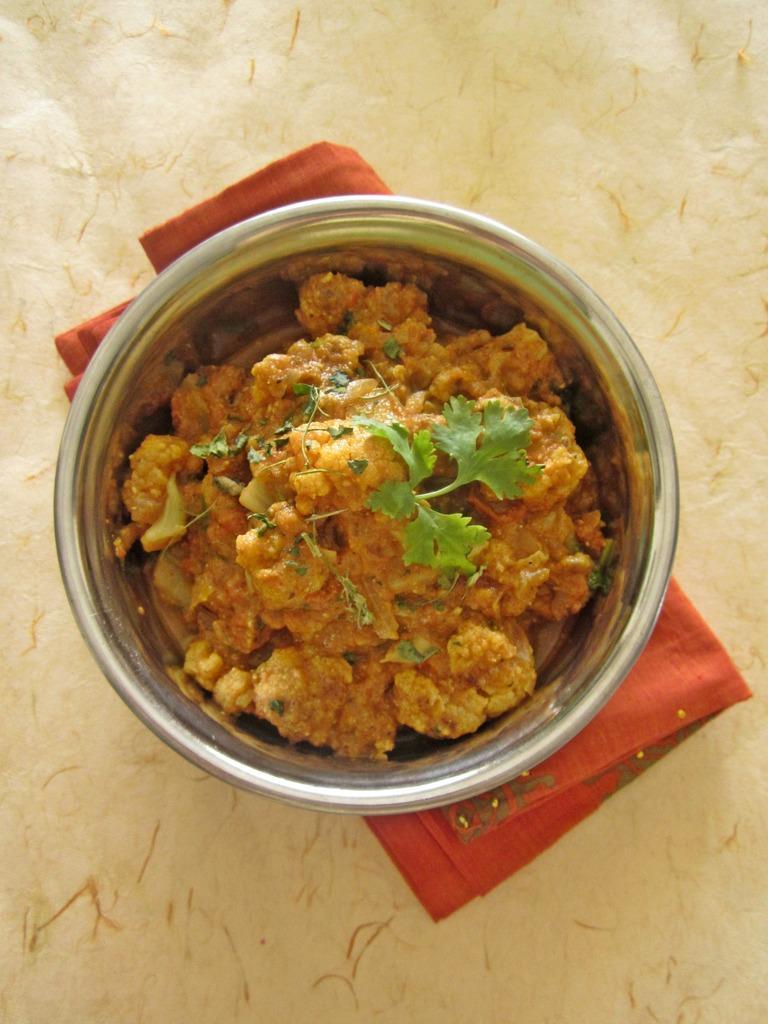Describe this image in one or two sentences. In this image we can see some food item which is in a bowl which is on red cloth and the background of the image there is white color cloth. 